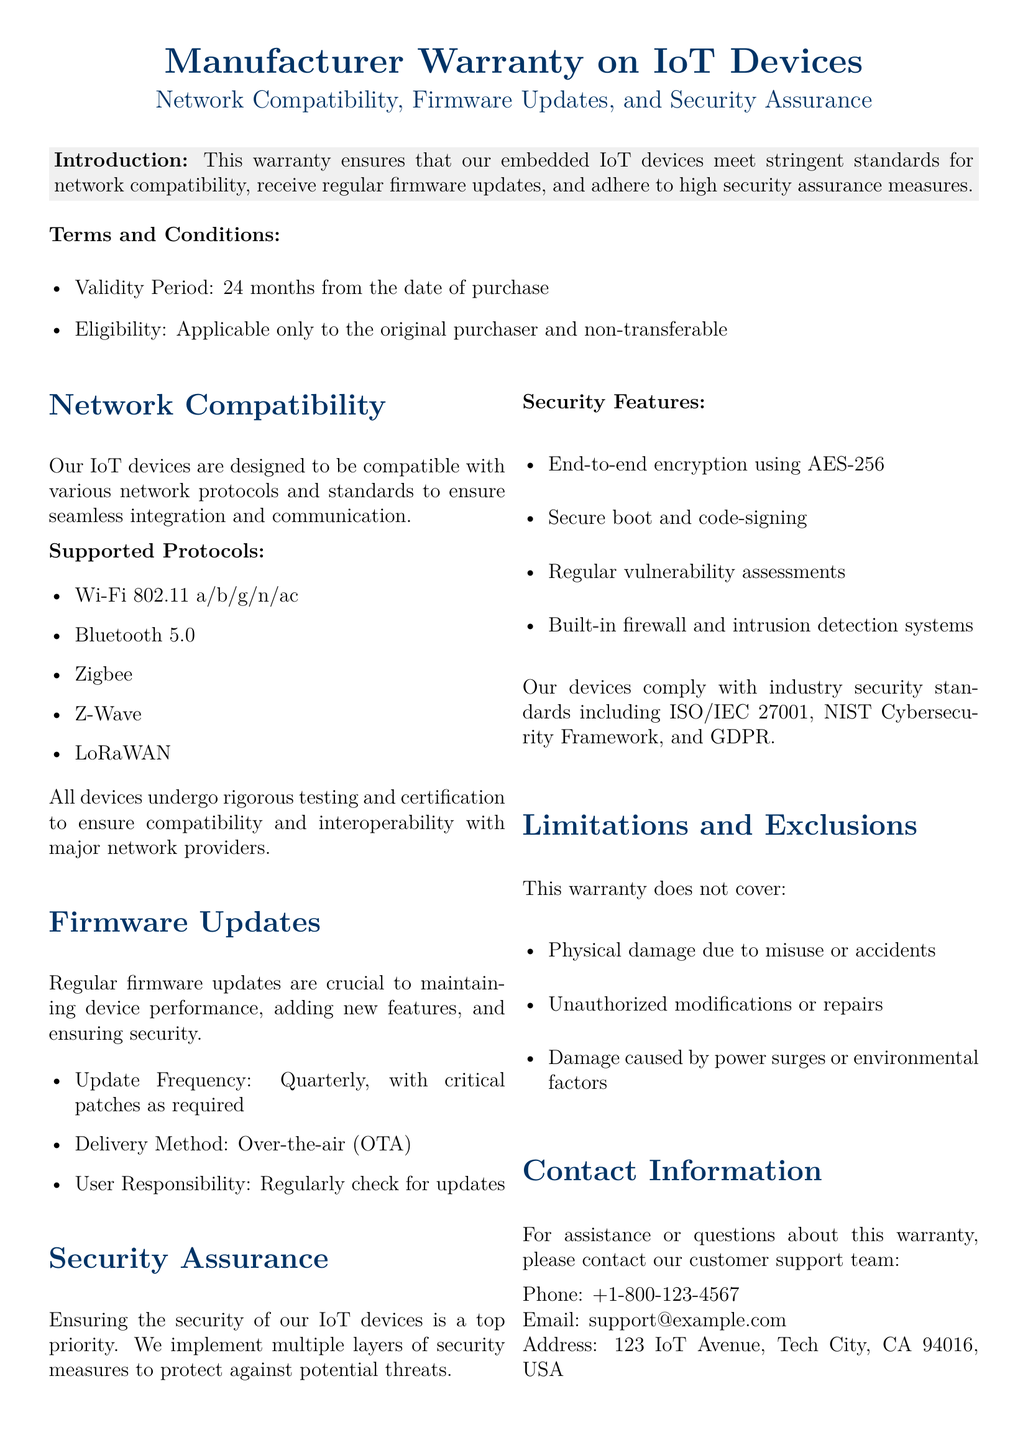What is the validity period of the warranty? The validity period is stated in the terms and conditions section of the document, which indicates it lasts for 24 months from the date of purchase.
Answer: 24 months Who is eligible for the warranty? Eligibility criteria are outlined in the terms and conditions, specifying that it applies only to the original purchaser and is non-transferable.
Answer: Original purchaser How often are firmware updates delivered? The firmware updates section describes the frequency of updates as quarterly, with critical patches as required.
Answer: Quarterly What encryption standard is used for security assurance? The security features section lists end-to-end encryption using a specific standard for safeguarding device data.
Answer: AES-256 Which network protocols are supported? The supported protocols section identifies several protocols compatible with the IoT devices.
Answer: Wi-Fi 802.11 a/b/g/n/ac, Bluetooth 5.0, Zigbee, Z-Wave, LoRaWAN What is the delivery method for firmware updates? The document specifies the method for delivering firmware updates, which is relevant to user interaction with the device updates.
Answer: Over-the-air (OTA) What type of damage is not covered by the warranty? The limitations and exclusions section specifies types of damage that are not covered under the warranty, which is important for understanding the warranty's boundaries.
Answer: Physical damage due to misuse or accidents What does the warranty ensure regarding network compatibility? The introduction establishes the warranty's purpose concerning compatibility and performance of embedded IoT devices across various networks.
Answer: Network compatibility What is the customer support phone number? The contact information section provides necessary details for customer support to assist with warranty inquiries, which is crucial for users who need help.
Answer: +1-800-123-4567 